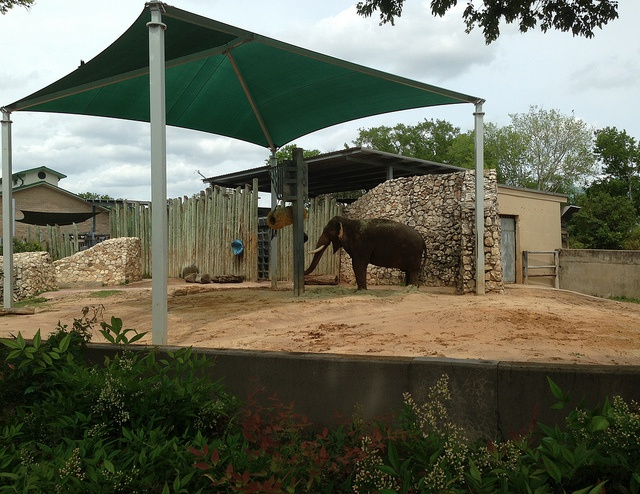Describe the objects in this image and their specific colors. I can see a elephant in darkgreen, black, and gray tones in this image. 